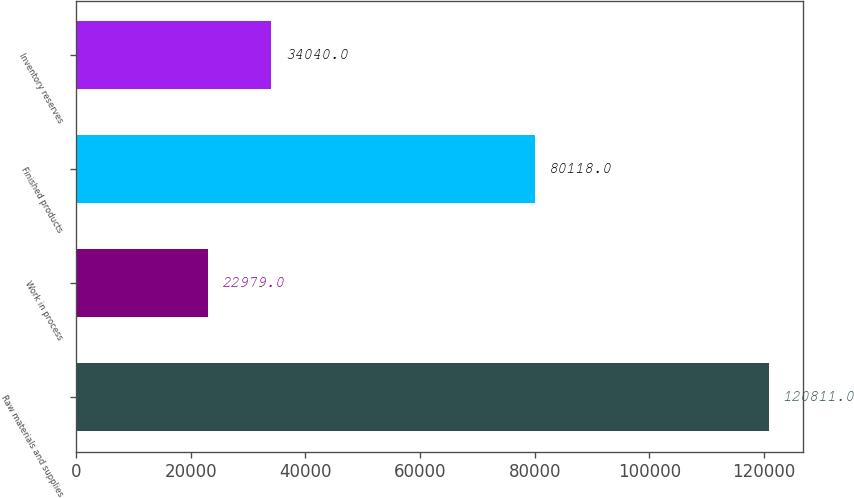Convert chart to OTSL. <chart><loc_0><loc_0><loc_500><loc_500><bar_chart><fcel>Raw materials and supplies<fcel>Work in process<fcel>Finished products<fcel>Inventory reserves<nl><fcel>120811<fcel>22979<fcel>80118<fcel>34040<nl></chart> 